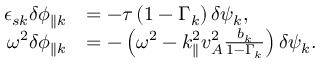Convert formula to latex. <formula><loc_0><loc_0><loc_500><loc_500>\begin{array} { r l } { \epsilon _ { s { k } } \delta \phi _ { \| { k } } } & { = - \tau \left ( 1 - \Gamma _ { k } \right ) \delta \psi _ { k } , } \\ { \omega ^ { 2 } \delta \phi _ { \| { k } } } & { = - \left ( \omega ^ { 2 } - k _ { \| } ^ { 2 } v _ { A } ^ { 2 } \frac { b _ { k } } { 1 - \Gamma _ { k } } \right ) \delta \psi _ { k } . } \end{array}</formula> 